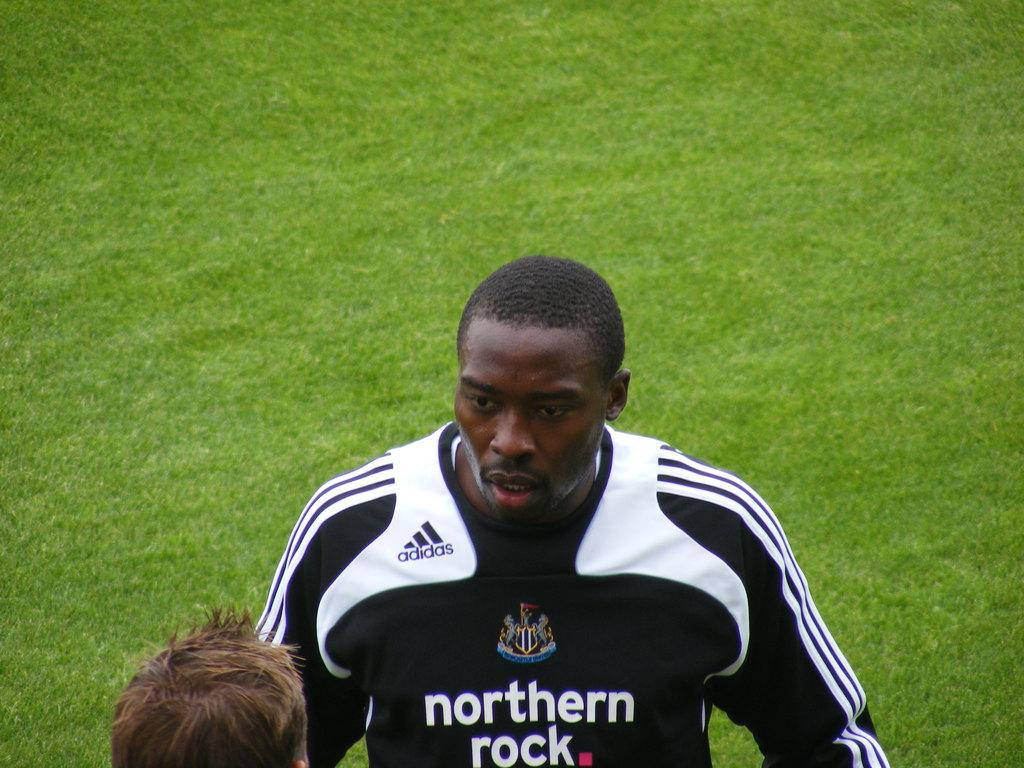Who is present in the image? There is a man in the image. What is the man wearing? The man is wearing a black and white t-shirt. What can be seen in the background of the image? There is grass visible in the background of the image. How many kittens are playing with the man in the image? There are no kittens present in the image. What time of day is it in the image, based on the hour? The provided facts do not mention the time of day or any hour, so it cannot be determined from the image. 